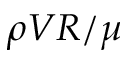<formula> <loc_0><loc_0><loc_500><loc_500>\rho V R / \mu</formula> 